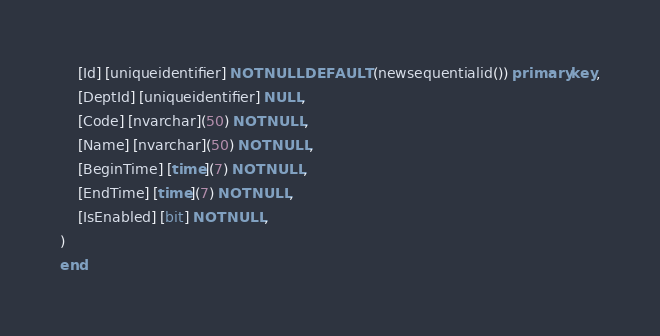Convert code to text. <code><loc_0><loc_0><loc_500><loc_500><_SQL_>	[Id] [uniqueidentifier] NOT NULL DEFAULT (newsequentialid()) primary key,
	[DeptId] [uniqueidentifier] NULL,
	[Code] [nvarchar](50) NOT NULL,
	[Name] [nvarchar](50) NOT NULL,
	[BeginTime] [time](7) NOT NULL,
	[EndTime] [time](7) NOT NULL,
	[IsEnabled] [bit] NOT NULL,
)
end
</code> 